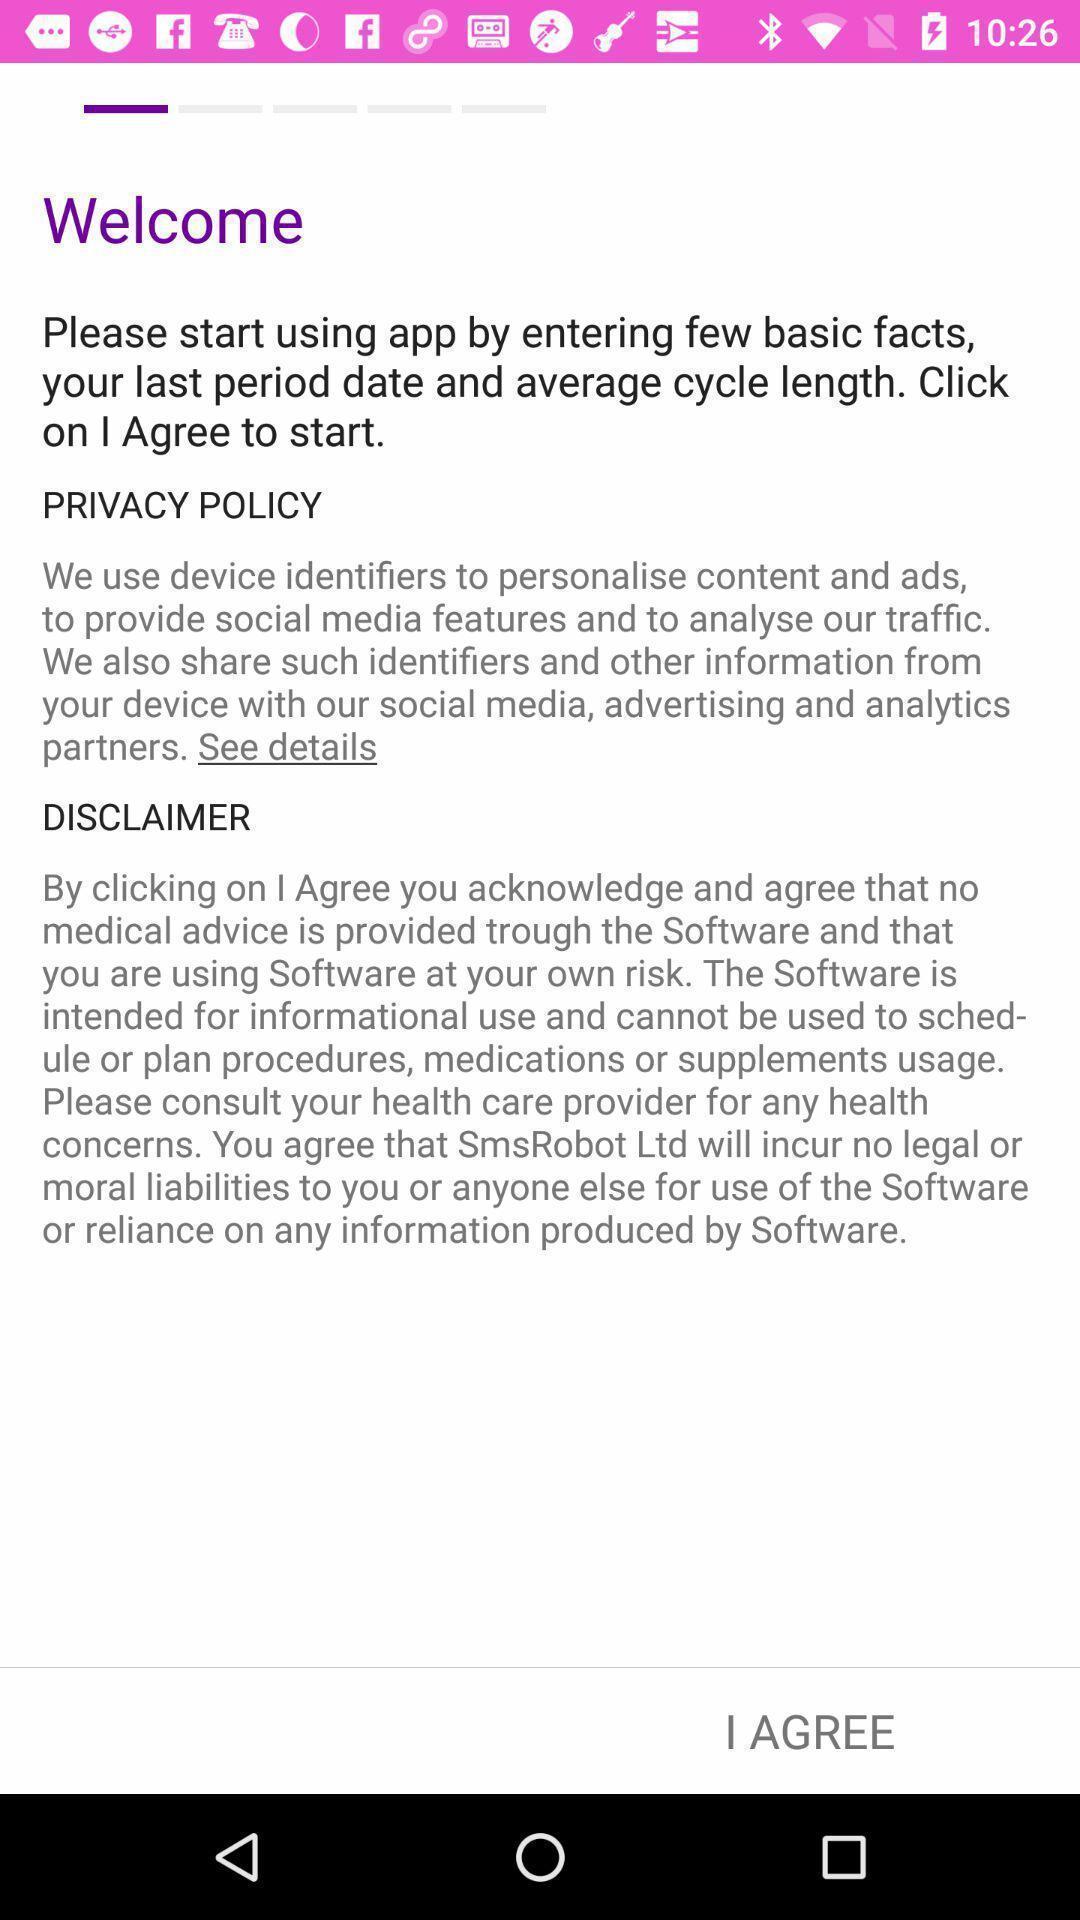Summarize the main components in this picture. Welcome page to the application with option. 